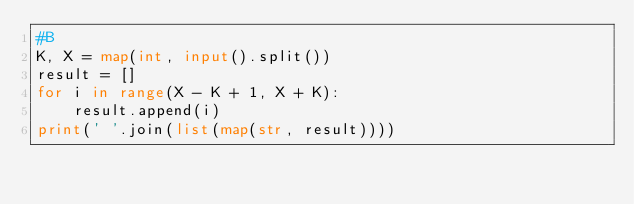<code> <loc_0><loc_0><loc_500><loc_500><_Python_>#B
K, X = map(int, input().split())
result = []
for i in range(X - K + 1, X + K):
    result.append(i)
print(' '.join(list(map(str, result))))</code> 